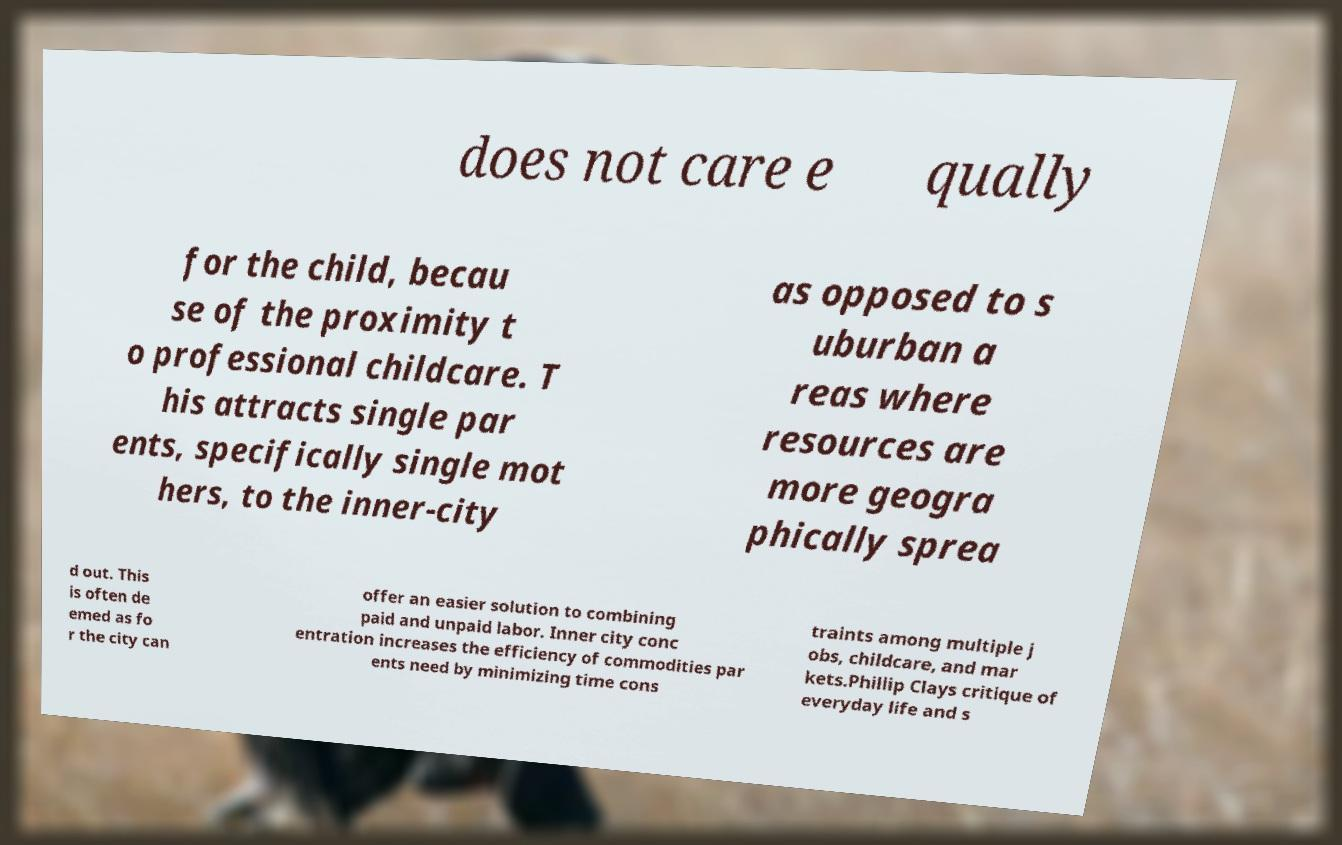Please identify and transcribe the text found in this image. does not care e qually for the child, becau se of the proximity t o professional childcare. T his attracts single par ents, specifically single mot hers, to the inner-city as opposed to s uburban a reas where resources are more geogra phically sprea d out. This is often de emed as fo r the city can offer an easier solution to combining paid and unpaid labor. Inner city conc entration increases the efficiency of commodities par ents need by minimizing time cons traints among multiple j obs, childcare, and mar kets.Phillip Clays critique of everyday life and s 